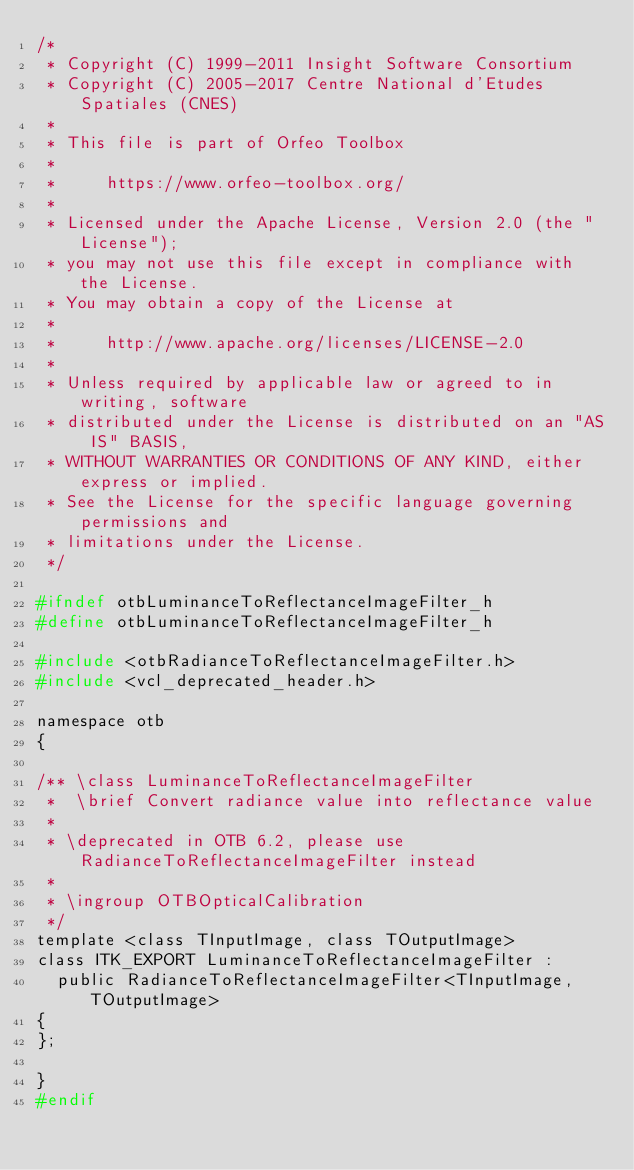Convert code to text. <code><loc_0><loc_0><loc_500><loc_500><_C_>/*
 * Copyright (C) 1999-2011 Insight Software Consortium
 * Copyright (C) 2005-2017 Centre National d'Etudes Spatiales (CNES)
 *
 * This file is part of Orfeo Toolbox
 *
 *     https://www.orfeo-toolbox.org/
 *
 * Licensed under the Apache License, Version 2.0 (the "License");
 * you may not use this file except in compliance with the License.
 * You may obtain a copy of the License at
 *
 *     http://www.apache.org/licenses/LICENSE-2.0
 *
 * Unless required by applicable law or agreed to in writing, software
 * distributed under the License is distributed on an "AS IS" BASIS,
 * WITHOUT WARRANTIES OR CONDITIONS OF ANY KIND, either express or implied.
 * See the License for the specific language governing permissions and
 * limitations under the License.
 */

#ifndef otbLuminanceToReflectanceImageFilter_h
#define otbLuminanceToReflectanceImageFilter_h

#include <otbRadianceToReflectanceImageFilter.h>
#include <vcl_deprecated_header.h>

namespace otb
{

/** \class LuminanceToReflectanceImageFilter
 *  \brief Convert radiance value into reflectance value
 *
 * \deprecated in OTB 6.2, please use RadianceToReflectanceImageFilter instead
 *
 * \ingroup OTBOpticalCalibration
 */
template <class TInputImage, class TOutputImage>
class ITK_EXPORT LuminanceToReflectanceImageFilter :
  public RadianceToReflectanceImageFilter<TInputImage,TOutputImage>
{
};

}
#endif
</code> 